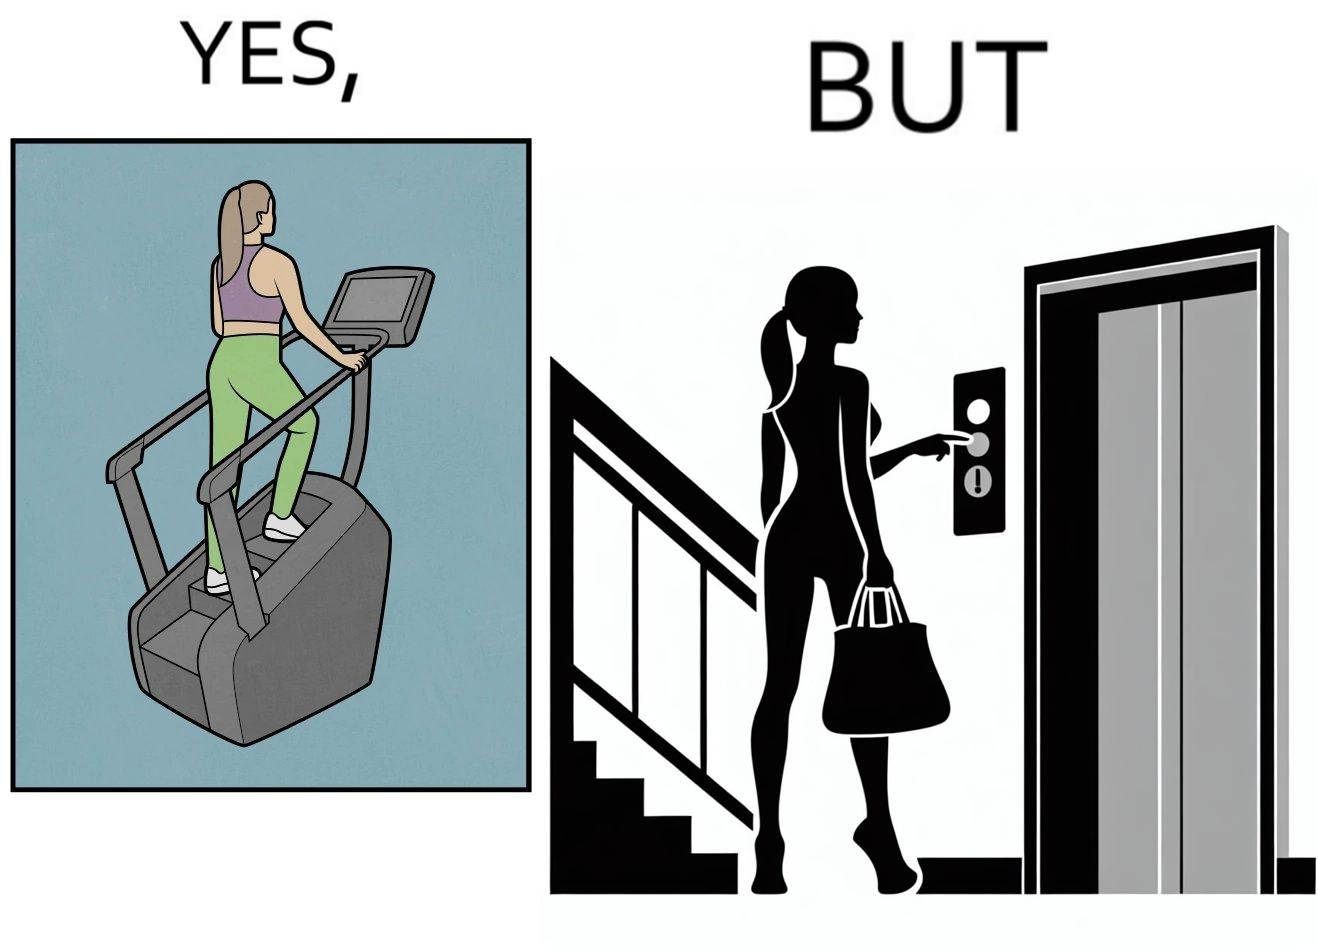Describe the content of this image. The image is ironic, because in the left image a woman is seen using the stair climber machine at the gym but the same woman is not ready to climb up some stairs for going to the gym and is calling for the lift 